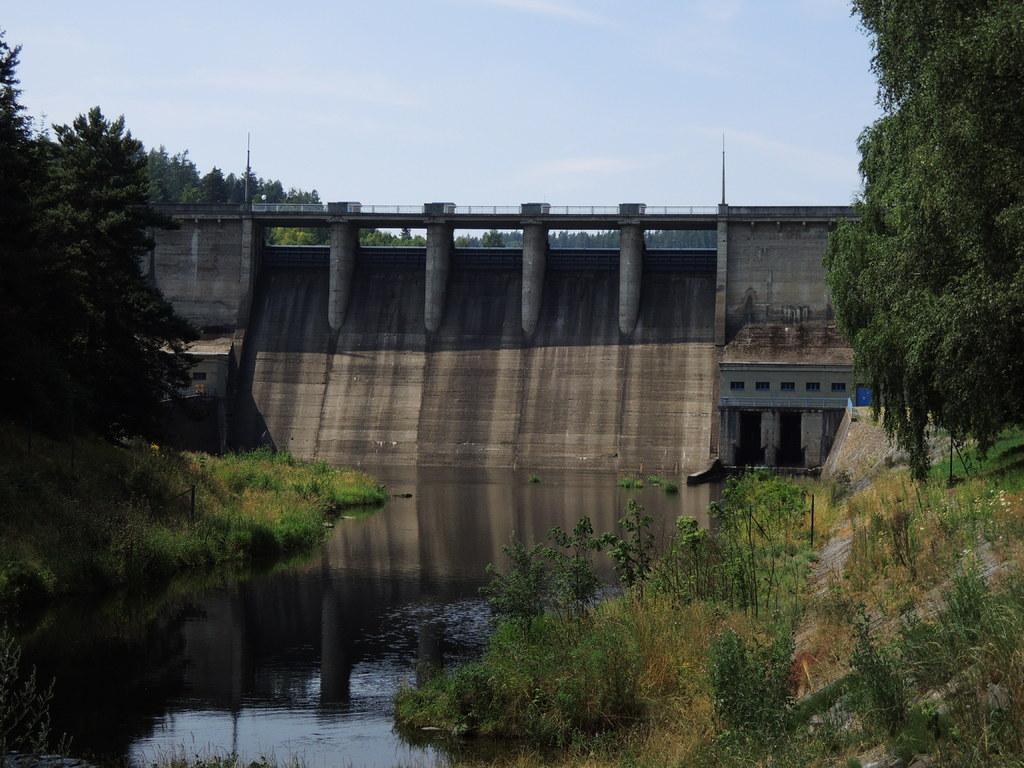How would you summarize this image in a sentence or two? In this image we can see the dam. We can also see the trees, grass, plants and also the water. Sky is also visible. 